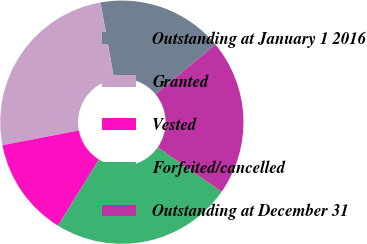<chart> <loc_0><loc_0><loc_500><loc_500><pie_chart><fcel>Outstanding at January 1 2016<fcel>Granted<fcel>Vested<fcel>Forfeited/cancelled<fcel>Outstanding at December 31<nl><fcel>16.78%<fcel>25.22%<fcel>13.18%<fcel>24.1%<fcel>20.72%<nl></chart> 